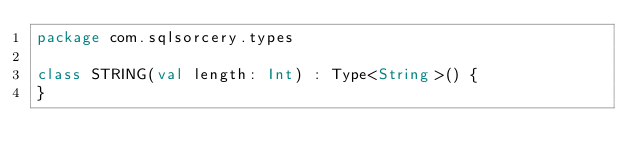<code> <loc_0><loc_0><loc_500><loc_500><_Kotlin_>package com.sqlsorcery.types

class STRING(val length: Int) : Type<String>() {
}
</code> 